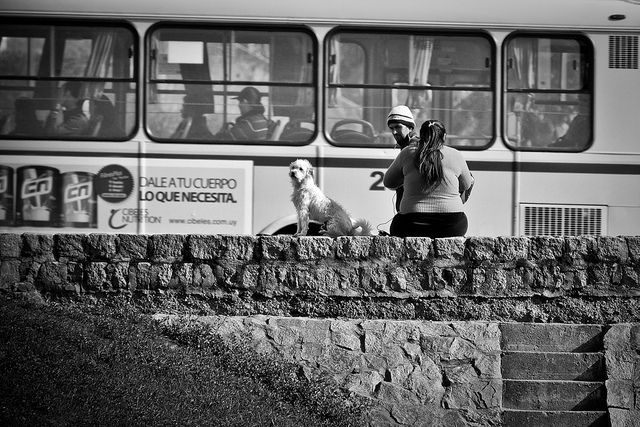Read and extract the text from this image. 2 DALEATUCUERPO LO CN CN 